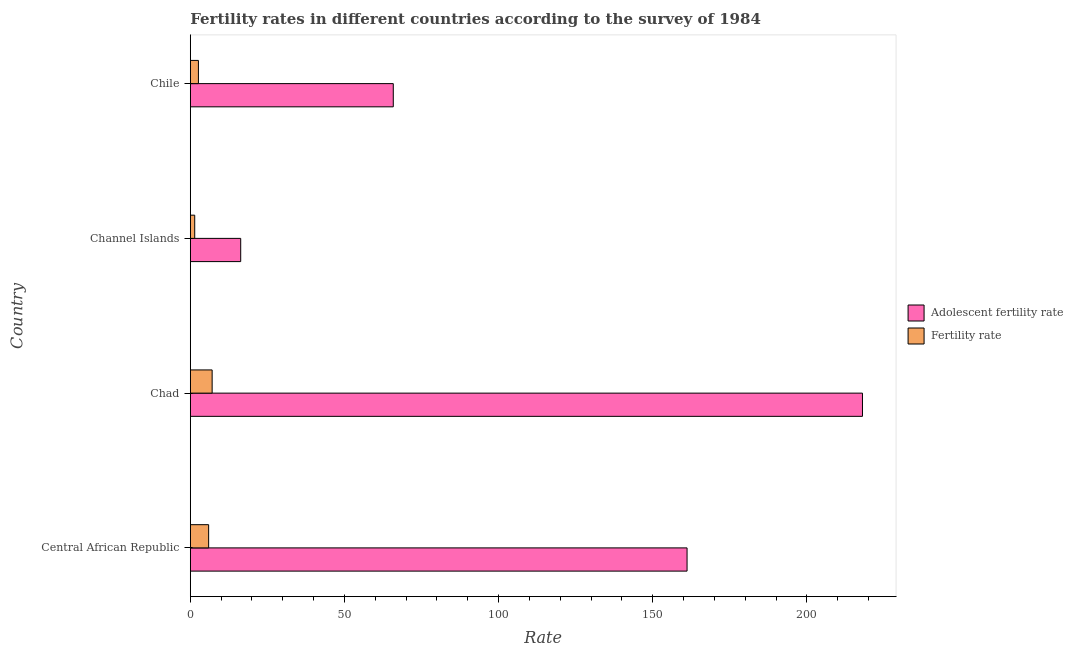How many groups of bars are there?
Offer a very short reply. 4. Are the number of bars on each tick of the Y-axis equal?
Give a very brief answer. Yes. How many bars are there on the 2nd tick from the bottom?
Give a very brief answer. 2. What is the label of the 4th group of bars from the top?
Offer a terse response. Central African Republic. What is the fertility rate in Chad?
Make the answer very short. 7.09. Across all countries, what is the maximum adolescent fertility rate?
Your answer should be compact. 218.04. Across all countries, what is the minimum fertility rate?
Make the answer very short. 1.43. In which country was the fertility rate maximum?
Ensure brevity in your answer.  Chad. In which country was the adolescent fertility rate minimum?
Offer a terse response. Channel Islands. What is the total fertility rate in the graph?
Give a very brief answer. 17.11. What is the difference between the adolescent fertility rate in Chad and that in Chile?
Keep it short and to the point. 152.2. What is the difference between the adolescent fertility rate in Chad and the fertility rate in Channel Islands?
Provide a succinct answer. 216.61. What is the average adolescent fertility rate per country?
Ensure brevity in your answer.  115.34. What is the difference between the adolescent fertility rate and fertility rate in Chile?
Give a very brief answer. 63.21. What is the ratio of the fertility rate in Chad to that in Channel Islands?
Keep it short and to the point. 4.94. Is the fertility rate in Central African Republic less than that in Chad?
Your answer should be very brief. Yes. Is the difference between the adolescent fertility rate in Central African Republic and Chad greater than the difference between the fertility rate in Central African Republic and Chad?
Provide a succinct answer. No. What is the difference between the highest and the second highest fertility rate?
Give a very brief answer. 1.14. What is the difference between the highest and the lowest fertility rate?
Provide a short and direct response. 5.66. In how many countries, is the fertility rate greater than the average fertility rate taken over all countries?
Your answer should be very brief. 2. Is the sum of the adolescent fertility rate in Chad and Chile greater than the maximum fertility rate across all countries?
Provide a short and direct response. Yes. What does the 1st bar from the top in Chile represents?
Offer a very short reply. Fertility rate. What does the 1st bar from the bottom in Chile represents?
Your response must be concise. Adolescent fertility rate. How many bars are there?
Offer a terse response. 8. How many countries are there in the graph?
Provide a short and direct response. 4. What is the difference between two consecutive major ticks on the X-axis?
Ensure brevity in your answer.  50. Does the graph contain any zero values?
Ensure brevity in your answer.  No. Does the graph contain grids?
Make the answer very short. No. What is the title of the graph?
Provide a succinct answer. Fertility rates in different countries according to the survey of 1984. What is the label or title of the X-axis?
Give a very brief answer. Rate. What is the label or title of the Y-axis?
Keep it short and to the point. Country. What is the Rate of Adolescent fertility rate in Central African Republic?
Offer a very short reply. 161.14. What is the Rate in Fertility rate in Central African Republic?
Provide a short and direct response. 5.95. What is the Rate of Adolescent fertility rate in Chad?
Your response must be concise. 218.04. What is the Rate in Fertility rate in Chad?
Offer a terse response. 7.09. What is the Rate of Adolescent fertility rate in Channel Islands?
Your answer should be compact. 16.35. What is the Rate of Fertility rate in Channel Islands?
Offer a terse response. 1.43. What is the Rate of Adolescent fertility rate in Chile?
Ensure brevity in your answer.  65.84. What is the Rate of Fertility rate in Chile?
Provide a succinct answer. 2.63. Across all countries, what is the maximum Rate in Adolescent fertility rate?
Provide a succinct answer. 218.04. Across all countries, what is the maximum Rate of Fertility rate?
Offer a terse response. 7.09. Across all countries, what is the minimum Rate in Adolescent fertility rate?
Your answer should be very brief. 16.35. Across all countries, what is the minimum Rate in Fertility rate?
Provide a short and direct response. 1.43. What is the total Rate in Adolescent fertility rate in the graph?
Ensure brevity in your answer.  461.38. What is the total Rate in Fertility rate in the graph?
Your answer should be very brief. 17.11. What is the difference between the Rate in Adolescent fertility rate in Central African Republic and that in Chad?
Provide a succinct answer. -56.9. What is the difference between the Rate of Fertility rate in Central African Republic and that in Chad?
Ensure brevity in your answer.  -1.14. What is the difference between the Rate of Adolescent fertility rate in Central African Republic and that in Channel Islands?
Offer a terse response. 144.79. What is the difference between the Rate in Fertility rate in Central African Republic and that in Channel Islands?
Offer a terse response. 4.52. What is the difference between the Rate in Adolescent fertility rate in Central African Republic and that in Chile?
Ensure brevity in your answer.  95.3. What is the difference between the Rate in Fertility rate in Central African Republic and that in Chile?
Offer a terse response. 3.32. What is the difference between the Rate in Adolescent fertility rate in Chad and that in Channel Islands?
Offer a very short reply. 201.69. What is the difference between the Rate of Fertility rate in Chad and that in Channel Islands?
Your answer should be very brief. 5.66. What is the difference between the Rate in Adolescent fertility rate in Chad and that in Chile?
Your answer should be compact. 152.2. What is the difference between the Rate of Fertility rate in Chad and that in Chile?
Give a very brief answer. 4.46. What is the difference between the Rate in Adolescent fertility rate in Channel Islands and that in Chile?
Give a very brief answer. -49.49. What is the difference between the Rate in Adolescent fertility rate in Central African Republic and the Rate in Fertility rate in Chad?
Provide a short and direct response. 154.05. What is the difference between the Rate of Adolescent fertility rate in Central African Republic and the Rate of Fertility rate in Channel Islands?
Your answer should be very brief. 159.71. What is the difference between the Rate in Adolescent fertility rate in Central African Republic and the Rate in Fertility rate in Chile?
Provide a succinct answer. 158.51. What is the difference between the Rate in Adolescent fertility rate in Chad and the Rate in Fertility rate in Channel Islands?
Your answer should be compact. 216.61. What is the difference between the Rate of Adolescent fertility rate in Chad and the Rate of Fertility rate in Chile?
Your answer should be very brief. 215.41. What is the difference between the Rate of Adolescent fertility rate in Channel Islands and the Rate of Fertility rate in Chile?
Give a very brief answer. 13.72. What is the average Rate in Adolescent fertility rate per country?
Keep it short and to the point. 115.34. What is the average Rate in Fertility rate per country?
Offer a terse response. 4.28. What is the difference between the Rate in Adolescent fertility rate and Rate in Fertility rate in Central African Republic?
Make the answer very short. 155.19. What is the difference between the Rate of Adolescent fertility rate and Rate of Fertility rate in Chad?
Your answer should be very brief. 210.95. What is the difference between the Rate of Adolescent fertility rate and Rate of Fertility rate in Channel Islands?
Offer a terse response. 14.92. What is the difference between the Rate in Adolescent fertility rate and Rate in Fertility rate in Chile?
Your answer should be compact. 63.21. What is the ratio of the Rate of Adolescent fertility rate in Central African Republic to that in Chad?
Your response must be concise. 0.74. What is the ratio of the Rate of Fertility rate in Central African Republic to that in Chad?
Offer a very short reply. 0.84. What is the ratio of the Rate of Adolescent fertility rate in Central African Republic to that in Channel Islands?
Make the answer very short. 9.86. What is the ratio of the Rate in Fertility rate in Central African Republic to that in Channel Islands?
Offer a very short reply. 4.15. What is the ratio of the Rate of Adolescent fertility rate in Central African Republic to that in Chile?
Provide a short and direct response. 2.45. What is the ratio of the Rate in Fertility rate in Central African Republic to that in Chile?
Provide a succinct answer. 2.26. What is the ratio of the Rate of Adolescent fertility rate in Chad to that in Channel Islands?
Keep it short and to the point. 13.34. What is the ratio of the Rate of Fertility rate in Chad to that in Channel Islands?
Make the answer very short. 4.94. What is the ratio of the Rate in Adolescent fertility rate in Chad to that in Chile?
Give a very brief answer. 3.31. What is the ratio of the Rate in Fertility rate in Chad to that in Chile?
Keep it short and to the point. 2.69. What is the ratio of the Rate in Adolescent fertility rate in Channel Islands to that in Chile?
Your answer should be compact. 0.25. What is the ratio of the Rate of Fertility rate in Channel Islands to that in Chile?
Offer a terse response. 0.54. What is the difference between the highest and the second highest Rate in Adolescent fertility rate?
Your response must be concise. 56.9. What is the difference between the highest and the second highest Rate in Fertility rate?
Give a very brief answer. 1.14. What is the difference between the highest and the lowest Rate of Adolescent fertility rate?
Offer a very short reply. 201.69. What is the difference between the highest and the lowest Rate of Fertility rate?
Provide a short and direct response. 5.66. 